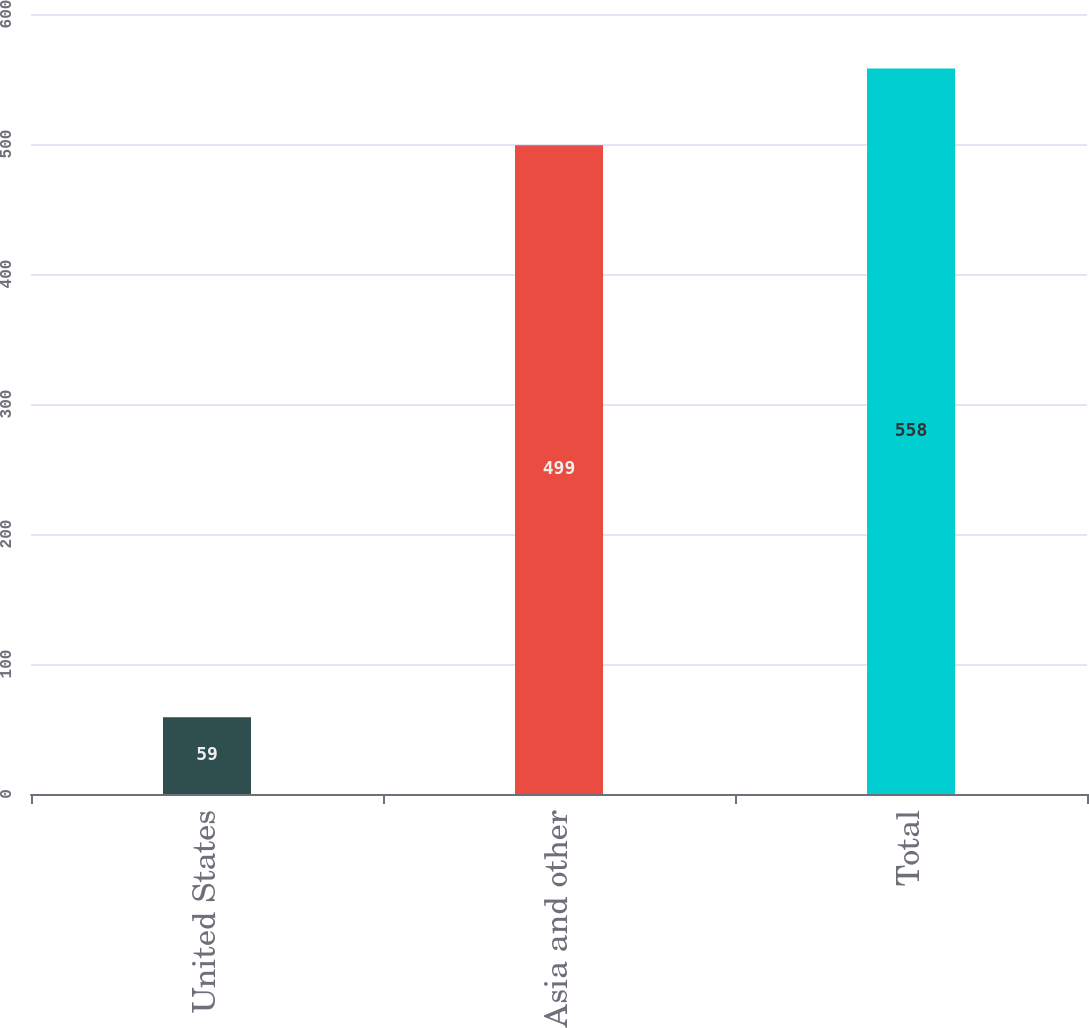<chart> <loc_0><loc_0><loc_500><loc_500><bar_chart><fcel>United States<fcel>Asia and other<fcel>Total<nl><fcel>59<fcel>499<fcel>558<nl></chart> 